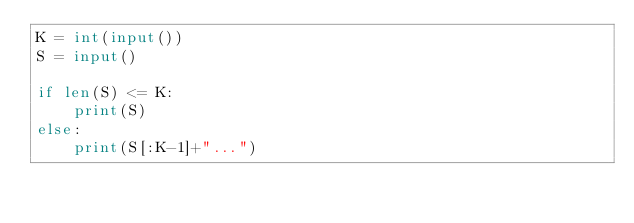<code> <loc_0><loc_0><loc_500><loc_500><_Python_>K = int(input())
S = input()

if len(S) <= K:
    print(S)
else:
    print(S[:K-1]+"...")</code> 